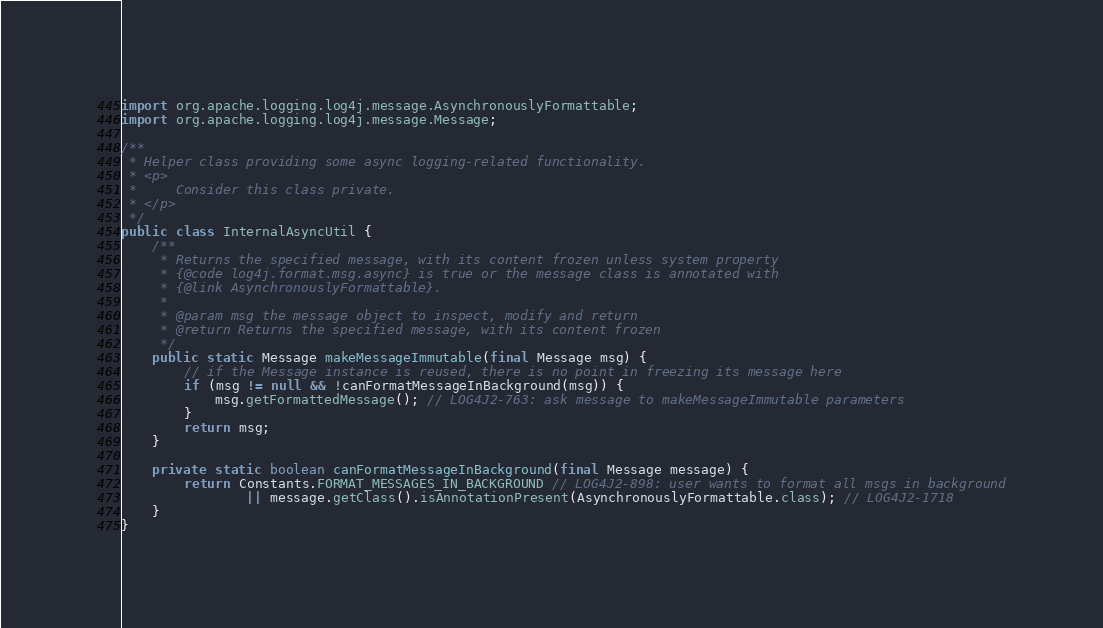Convert code to text. <code><loc_0><loc_0><loc_500><loc_500><_Java_>import org.apache.logging.log4j.message.AsynchronouslyFormattable;
import org.apache.logging.log4j.message.Message;

/**
 * Helper class providing some async logging-related functionality.
 * <p>
 *     Consider this class private.
 * </p>
 */
public class InternalAsyncUtil {
    /**
     * Returns the specified message, with its content frozen unless system property
     * {@code log4j.format.msg.async} is true or the message class is annotated with
     * {@link AsynchronouslyFormattable}.
     *
     * @param msg the message object to inspect, modify and return
     * @return Returns the specified message, with its content frozen
     */
    public static Message makeMessageImmutable(final Message msg) {
        // if the Message instance is reused, there is no point in freezing its message here
        if (msg != null && !canFormatMessageInBackground(msg)) {
            msg.getFormattedMessage(); // LOG4J2-763: ask message to makeMessageImmutable parameters
        }
        return msg;
    }

    private static boolean canFormatMessageInBackground(final Message message) {
        return Constants.FORMAT_MESSAGES_IN_BACKGROUND // LOG4J2-898: user wants to format all msgs in background
                || message.getClass().isAnnotationPresent(AsynchronouslyFormattable.class); // LOG4J2-1718
    }
}
</code> 